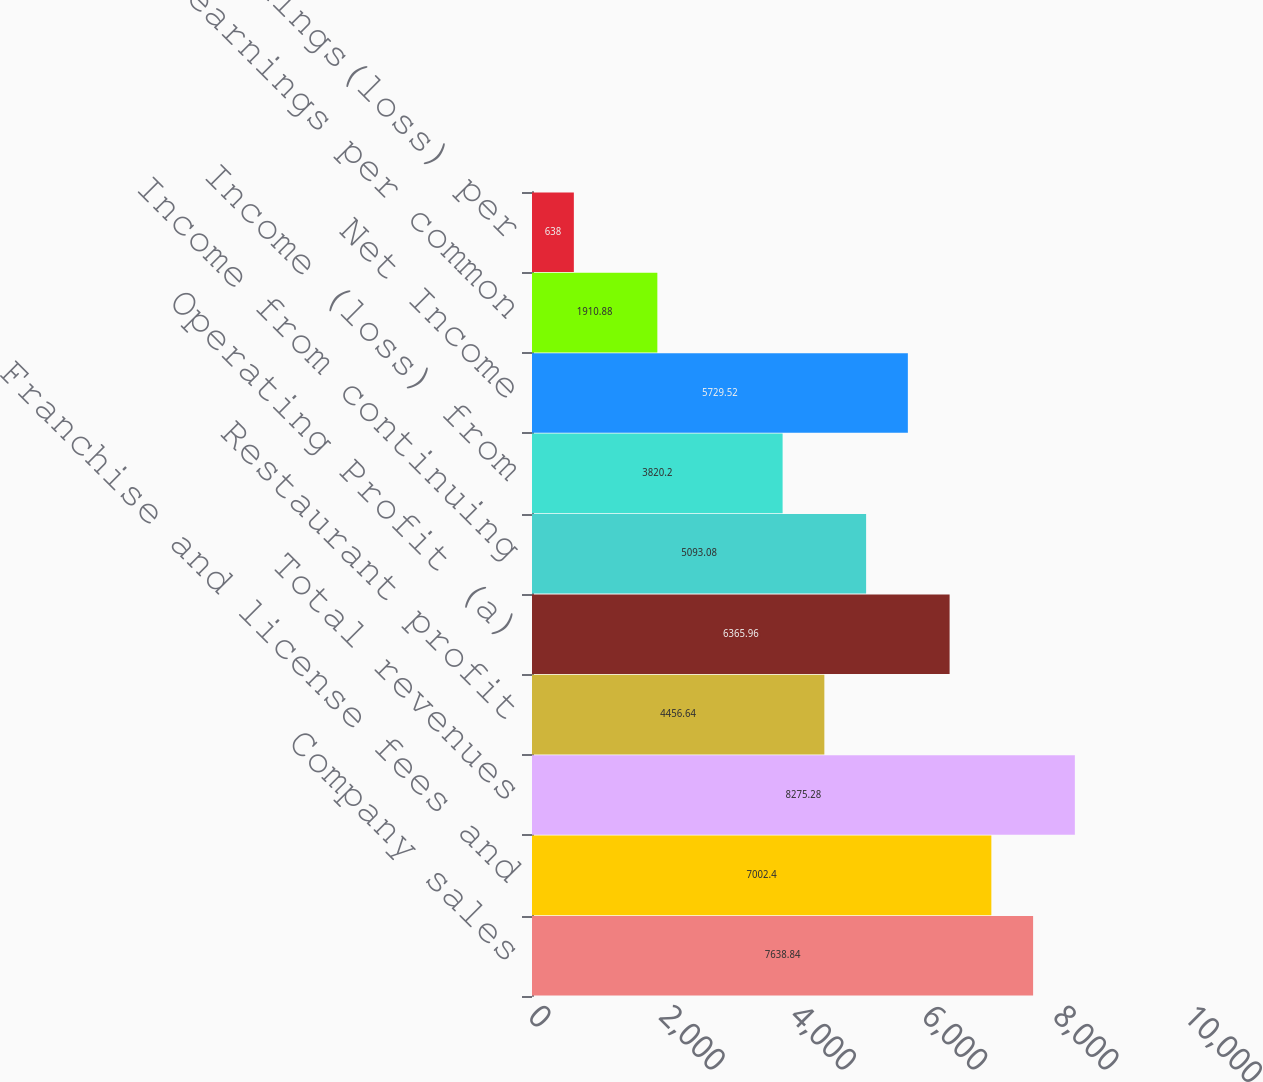<chart> <loc_0><loc_0><loc_500><loc_500><bar_chart><fcel>Company sales<fcel>Franchise and license fees and<fcel>Total revenues<fcel>Restaurant profit<fcel>Operating Profit (a)<fcel>Income from continuing<fcel>Income (loss) from<fcel>Net Income<fcel>Basic earnings per common<fcel>Basic earnings(loss) per<nl><fcel>7638.84<fcel>7002.4<fcel>8275.28<fcel>4456.64<fcel>6365.96<fcel>5093.08<fcel>3820.2<fcel>5729.52<fcel>1910.88<fcel>638<nl></chart> 